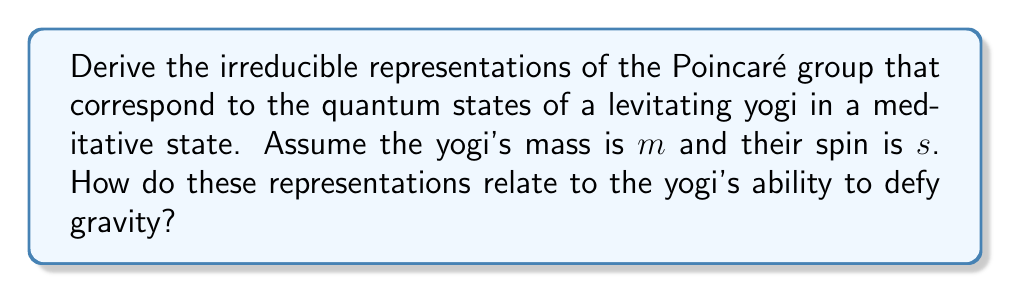Could you help me with this problem? To derive the irreducible representations of the Poincaré group for a levitating yogi, we follow these steps:

1. Recall that the Poincaré group is the semi-direct product of translations and Lorentz transformations: $ISO(3,1) = \mathbb{R}^4 \rtimes SO(3,1)$.

2. Use Wigner's classification of particles based on mass and spin. For a yogi with mass $m > 0$ and spin $s$, we consider massive representations.

3. The little group for massive particles is $SO(3)$, the rotation group in 3D space.

4. The irreducible representations are labeled by the mass $m$ and the spin $s$. They are given by:

   $$\mathcal{H}_{m,s} = L^2(\mathbb{R}^3) \otimes \mathbb{C}^{2s+1}$$

   where $L^2(\mathbb{R}^3)$ represents the spatial wavefunction and $\mathbb{C}^{2s+1}$ is the spin space.

5. The action of the Poincaré group on these states is given by:

   $$U(a,\Lambda)|p,\sigma\rangle = e^{ip\cdot a} \sum_{\sigma'} D^s_{\sigma'\sigma}(W(\Lambda,p))|\Lambda p,\sigma'\rangle$$

   where $a$ is a translation, $\Lambda$ is a Lorentz transformation, $D^s$ is the $(2s+1)$-dimensional representation of $SU(2)$, and $W(\Lambda,p)$ is the Wigner rotation.

6. For a levitating yogi, we are particularly interested in the representation of the subgroup of translations along the vertical axis, which corresponds to changes in height:

   $$U(a_z)|p,\sigma\rangle = e^{ip_z a_z}|p,\sigma\rangle$$

7. The ability to defy gravity is related to the yogi's capacity to maintain a non-zero expectation value for the height operator $Z$ in this representation:

   $$\langle Z \rangle = \langle \psi|Z|\psi \rangle > 0$$

   where $|\psi\rangle$ is the yogi's quantum state in the representation $\mathcal{H}_{m,s}$.

8. The yogi's meditative state can be seen as a superposition of momentum eigenstates with a distribution peaked at $p_z = 0$, allowing for a stable levitation.
Answer: $\mathcal{H}_{m,s} = L^2(\mathbb{R}^3) \otimes \mathbb{C}^{2s+1}$, with $U(a,\Lambda)|p,\sigma\rangle = e^{ip\cdot a} \sum_{\sigma'} D^s_{\sigma'\sigma}(W(\Lambda,p))|\Lambda p,\sigma'\rangle$. Levitation corresponds to $\langle Z \rangle > 0$ in this representation. 